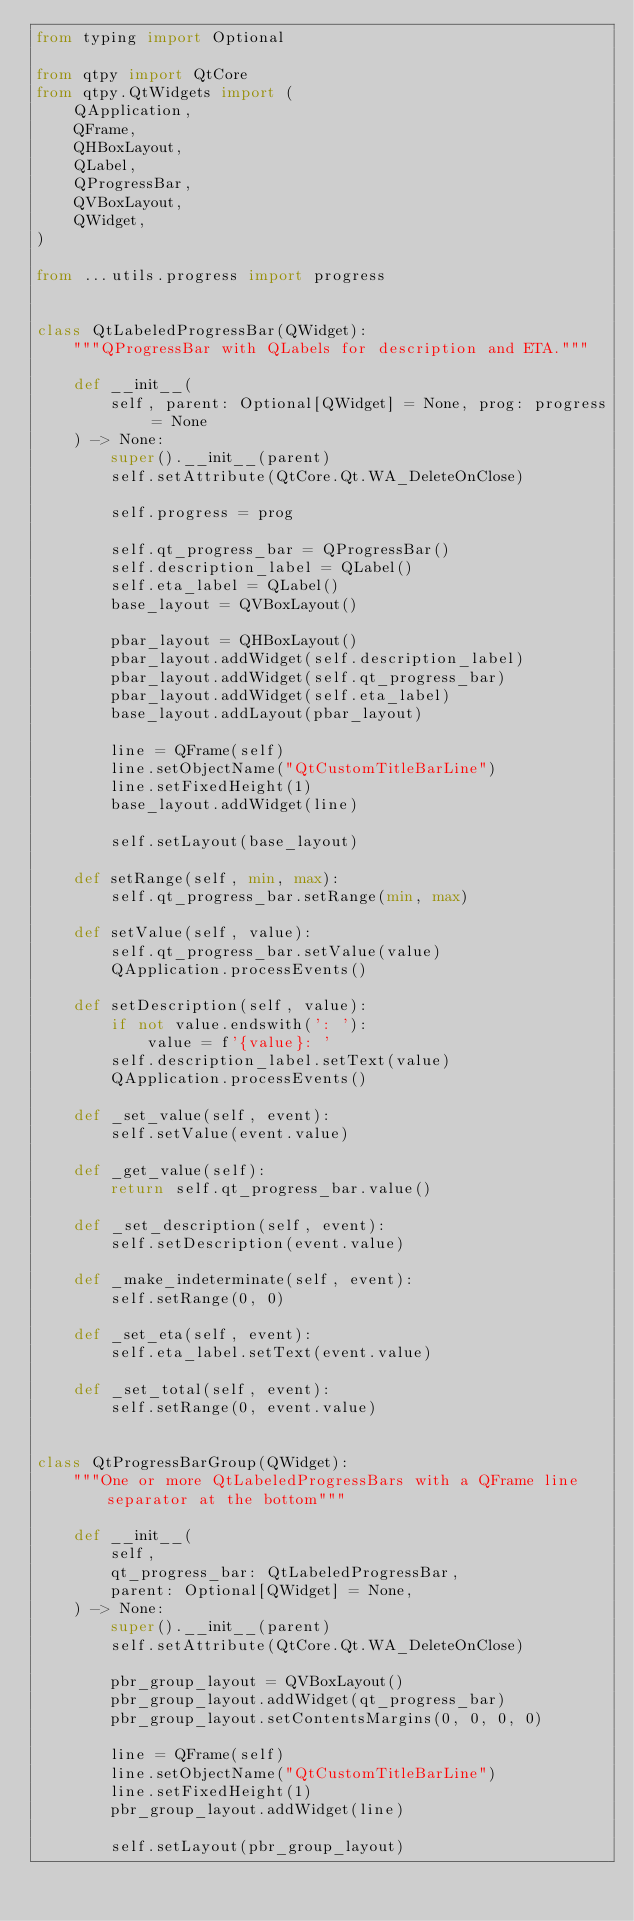Convert code to text. <code><loc_0><loc_0><loc_500><loc_500><_Python_>from typing import Optional

from qtpy import QtCore
from qtpy.QtWidgets import (
    QApplication,
    QFrame,
    QHBoxLayout,
    QLabel,
    QProgressBar,
    QVBoxLayout,
    QWidget,
)

from ...utils.progress import progress


class QtLabeledProgressBar(QWidget):
    """QProgressBar with QLabels for description and ETA."""

    def __init__(
        self, parent: Optional[QWidget] = None, prog: progress = None
    ) -> None:
        super().__init__(parent)
        self.setAttribute(QtCore.Qt.WA_DeleteOnClose)

        self.progress = prog

        self.qt_progress_bar = QProgressBar()
        self.description_label = QLabel()
        self.eta_label = QLabel()
        base_layout = QVBoxLayout()

        pbar_layout = QHBoxLayout()
        pbar_layout.addWidget(self.description_label)
        pbar_layout.addWidget(self.qt_progress_bar)
        pbar_layout.addWidget(self.eta_label)
        base_layout.addLayout(pbar_layout)

        line = QFrame(self)
        line.setObjectName("QtCustomTitleBarLine")
        line.setFixedHeight(1)
        base_layout.addWidget(line)

        self.setLayout(base_layout)

    def setRange(self, min, max):
        self.qt_progress_bar.setRange(min, max)

    def setValue(self, value):
        self.qt_progress_bar.setValue(value)
        QApplication.processEvents()

    def setDescription(self, value):
        if not value.endswith(': '):
            value = f'{value}: '
        self.description_label.setText(value)
        QApplication.processEvents()

    def _set_value(self, event):
        self.setValue(event.value)

    def _get_value(self):
        return self.qt_progress_bar.value()

    def _set_description(self, event):
        self.setDescription(event.value)

    def _make_indeterminate(self, event):
        self.setRange(0, 0)

    def _set_eta(self, event):
        self.eta_label.setText(event.value)

    def _set_total(self, event):
        self.setRange(0, event.value)


class QtProgressBarGroup(QWidget):
    """One or more QtLabeledProgressBars with a QFrame line separator at the bottom"""

    def __init__(
        self,
        qt_progress_bar: QtLabeledProgressBar,
        parent: Optional[QWidget] = None,
    ) -> None:
        super().__init__(parent)
        self.setAttribute(QtCore.Qt.WA_DeleteOnClose)

        pbr_group_layout = QVBoxLayout()
        pbr_group_layout.addWidget(qt_progress_bar)
        pbr_group_layout.setContentsMargins(0, 0, 0, 0)

        line = QFrame(self)
        line.setObjectName("QtCustomTitleBarLine")
        line.setFixedHeight(1)
        pbr_group_layout.addWidget(line)

        self.setLayout(pbr_group_layout)
</code> 